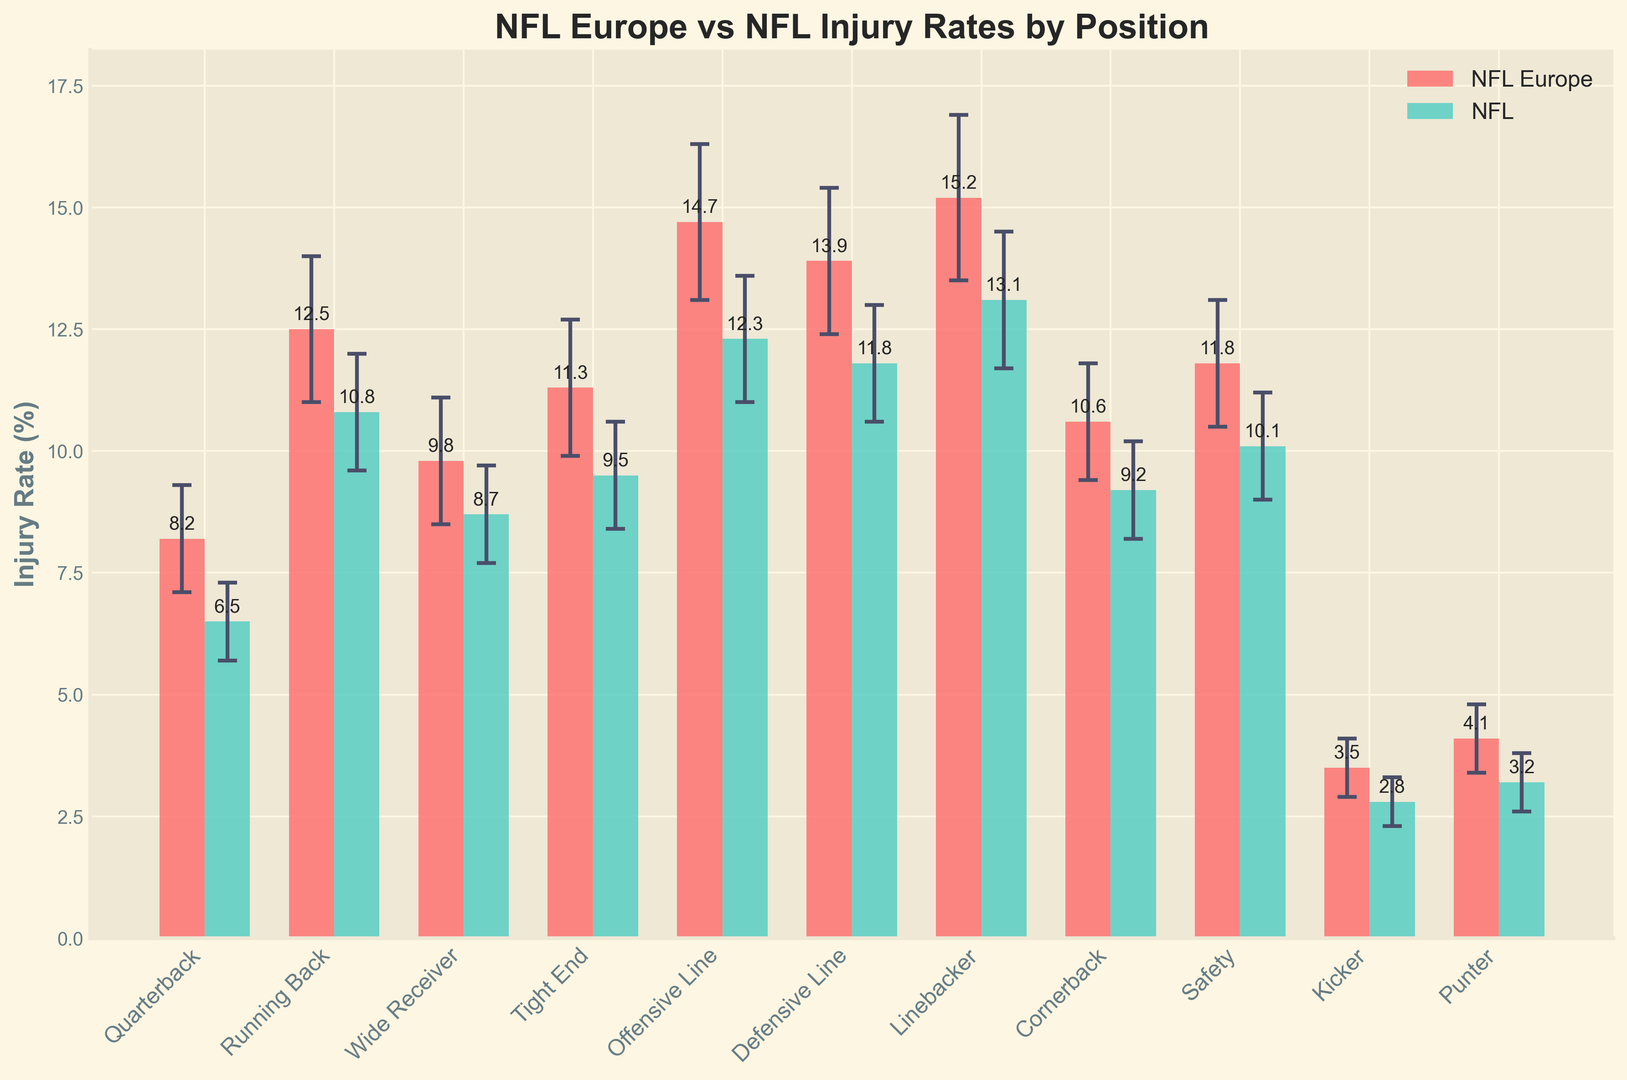What's the difference in the injury rate between linebackers in NFL Europe and NFL? To find the difference, subtract the NFL injury rate for linebackers from the NFL Europe injury rate for linebackers. NFL Europe has 15.2%, and NFL has 13.1%. Thus, the difference is 15.2% - 13.1%.
Answer: 2.1% Which position in NFL Europe has the lowest injury rate? By visually inspecting the height of the bars for NFL Europe, the position with the shortest bar represents the lowest injury rate. The lowest bar for NFL Europe is for the Kicker position.
Answer: Kicker How do the injury rates for offensive and defensive lines compare in the NFL? Compare the heights of the bars for the NFL rates of both positions. For the offensive line, the bar shows 12.3%, and for the defensive line, it shows 11.8%. Therefore, the offensive line has a higher injury rate.
Answer: Offensive line is higher What is the average injury rate for Quarterbacks and Wide Receivers in NFL Europe? Add the injury rates for Quarterbacks and Wide Receivers and divide by 2. The rates are 8.2% for Quarterbacks and 9.8% for Wide Receivers. So, (8.2 + 9.8) / 2 = 9%.
Answer: 9% Is there any position where the NFL injury rate is higher than the NFL Europe injury rate? Compare each pair of bars (NFL Europe and NFL) for every position. Upon inspection, none of the NFL bars are higher than their corresponding NFL Europe bars.
Answer: No What is the combined injury rate error for the Punter position in NFL Europe and NFL? Add the error rates for Punters from both leagues. NFL Europe has an error of 0.7%, and the NFL has an error of 0.6%. Thus, 0.7% + 0.6% = 1.3%.
Answer: 1.3% Which league has a higher injury rate for Tight Ends, and by how much? Compare the injury rates for Tight Ends in both leagues. NFL Europe has an injury rate of 11.3%, and the NFL has 9.5%. The difference is 11.3% - 9.5%.
Answer: NFL Europe by 1.8% How does the error margin for Running Backs in NFL Europe compare to that in the NFL? Look at the error values for Running Backs in both leagues. NFL Europe has 1.5% and the NFL has 1.2%. So, the NFL Europe error is higher than the NFL error.
Answer: Higher in NFL Europe What's the total injury rate for Safeties in both NFL Europe and NFL? Add the injury rates for Safeties in both leagues. NFL Europe shows 11.8%, and the NFL shows 10.1%. So, 11.8% + 10.1% = 21.9%.
Answer: 21.9% Which position in both leagues has one of the smallest differences in injury rates? Find the positions where the difference between the injury rates of NFL Europe and NFL is smallest. Comparative checking reveals that the Punter and Kicker positions have the smallest differences.
Answer: Punter or Kicker 